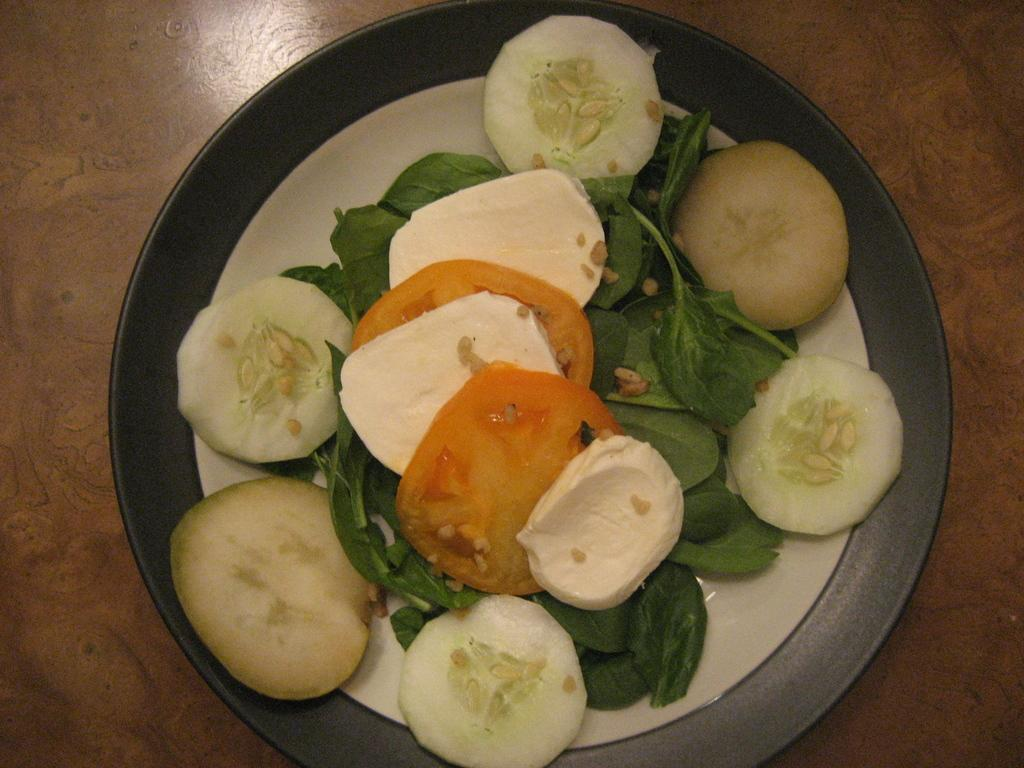What is present on the table in the image? There is a plate on the table in the image. What is on the plate? The plate contains slices of cucumber, slices of tomato, other vegetables, and leafy vegetables. Can you describe the vegetables on the plate? The plate contains slices of cucumber, slices of tomato, other vegetables, and leafy vegetables. What type of watch can be seen on the plate? There is no watch present on the plate; it contains vegetables. 